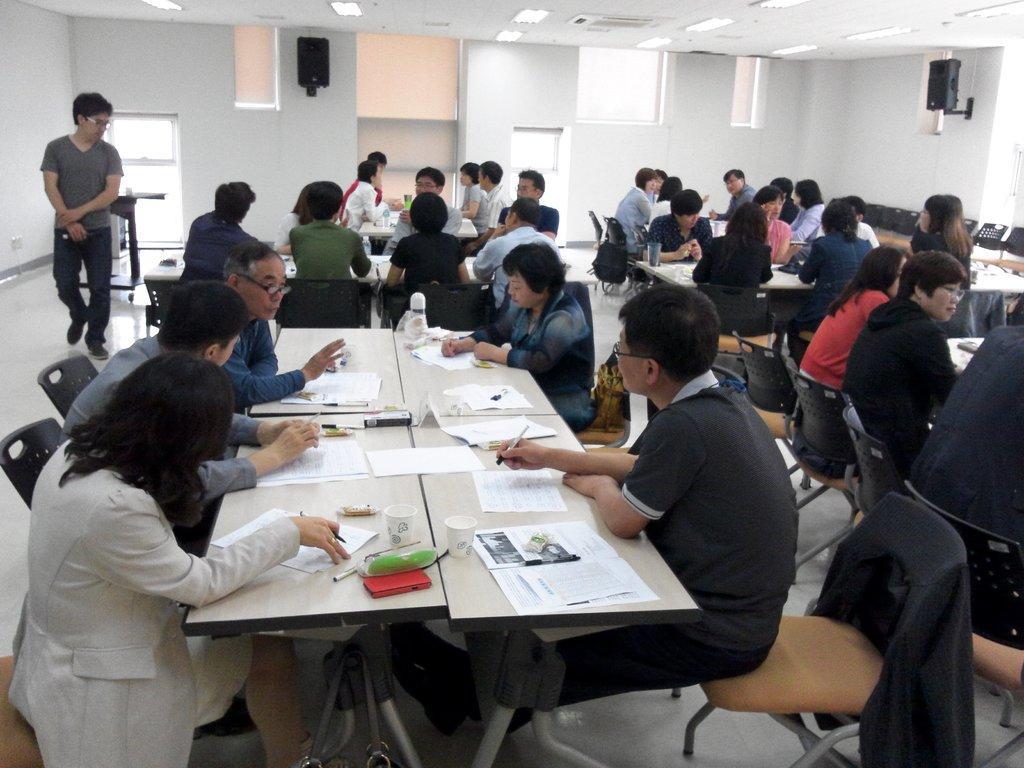Describe this image in one or two sentences. In this image i can see a group of people sitting on the chairs in front of a table and on the table i can see few papers, coffee cups, pens and mobiles. To the left of the image i can see a person standing, and in the background i can see a wall and a set of speakers. 